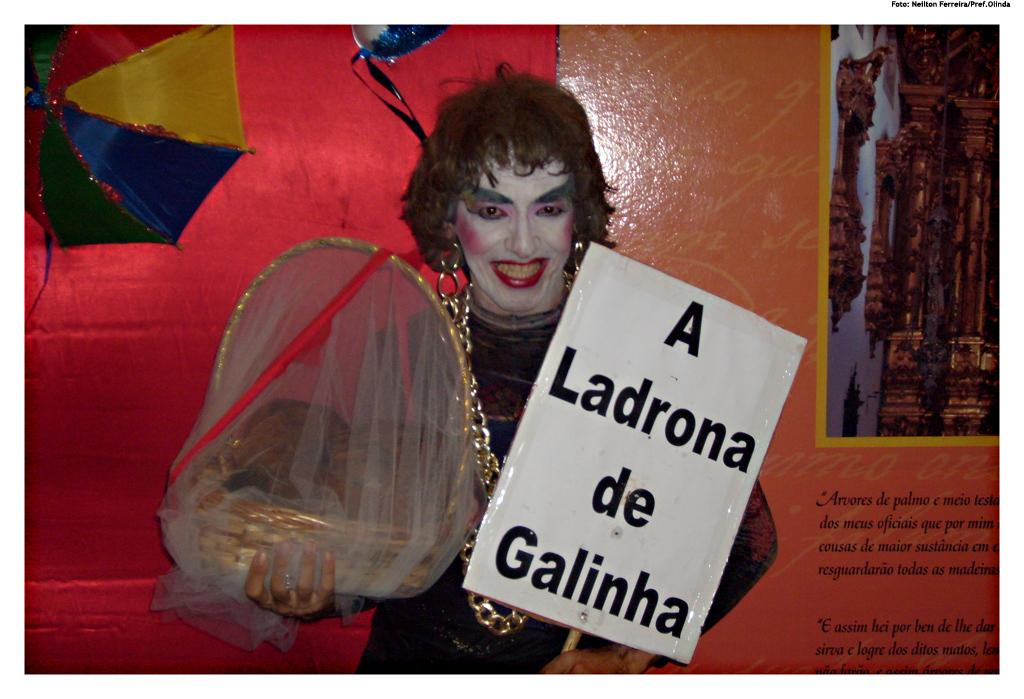What is the person in the image holding in their hands? The person is holding a basket and a whiteboard in their hands. What is the person wearing in the image? The person is wearing a black dress. Can you describe any other objects or features in the background of the image? There is a colorful umbrella visible in the background. How many sisters does the person in the image have? There is no information about the person's sisters in the image, so it cannot be determined. 